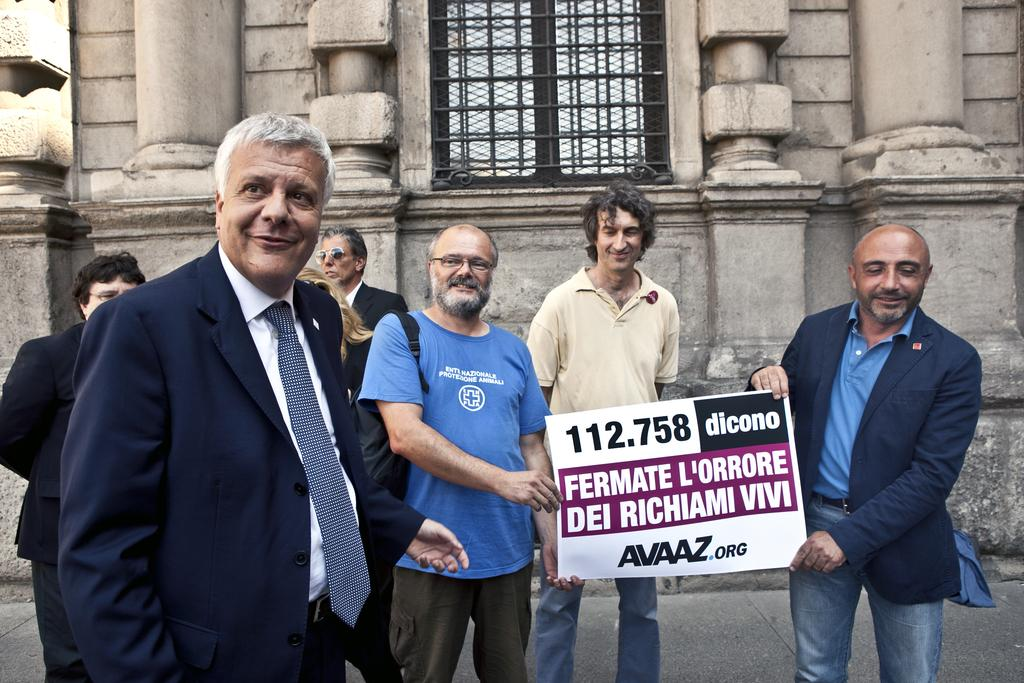What are the people in the image doing? The people in the image are holding a poster in the center of the image. What can be seen in the background of the image? There is a building and a window in the background of the image. What is at the bottom of the image? There is a road at the bottom of the image. What type of trousers are the people wearing in the image? There is no information about the people's clothing in the image, so we cannot determine what type of trousers they might be wearing. 